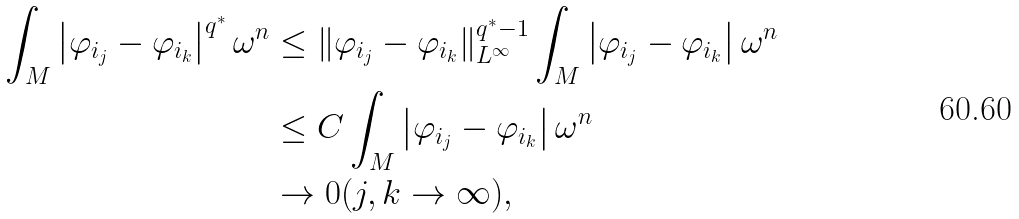<formula> <loc_0><loc_0><loc_500><loc_500>\int _ { M } \left | \varphi _ { i _ { j } } - \varphi _ { i _ { k } } \right | ^ { q ^ { * } } \omega ^ { n } & \leq \| \varphi _ { i _ { j } } - \varphi _ { i _ { k } } \| ^ { q ^ { * } - 1 } _ { L ^ { \infty } } \int _ { M } \left | \varphi _ { i _ { j } } - \varphi _ { i _ { k } } \right | \omega ^ { n } \\ & \leq C \int _ { M } \left | \varphi _ { i _ { j } } - \varphi _ { i _ { k } } \right | \omega ^ { n } \\ & \to 0 ( j , k \to \infty ) ,</formula> 